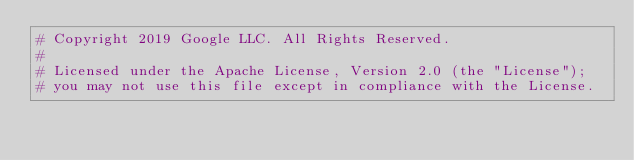<code> <loc_0><loc_0><loc_500><loc_500><_Python_># Copyright 2019 Google LLC. All Rights Reserved.
#
# Licensed under the Apache License, Version 2.0 (the "License");
# you may not use this file except in compliance with the License.</code> 